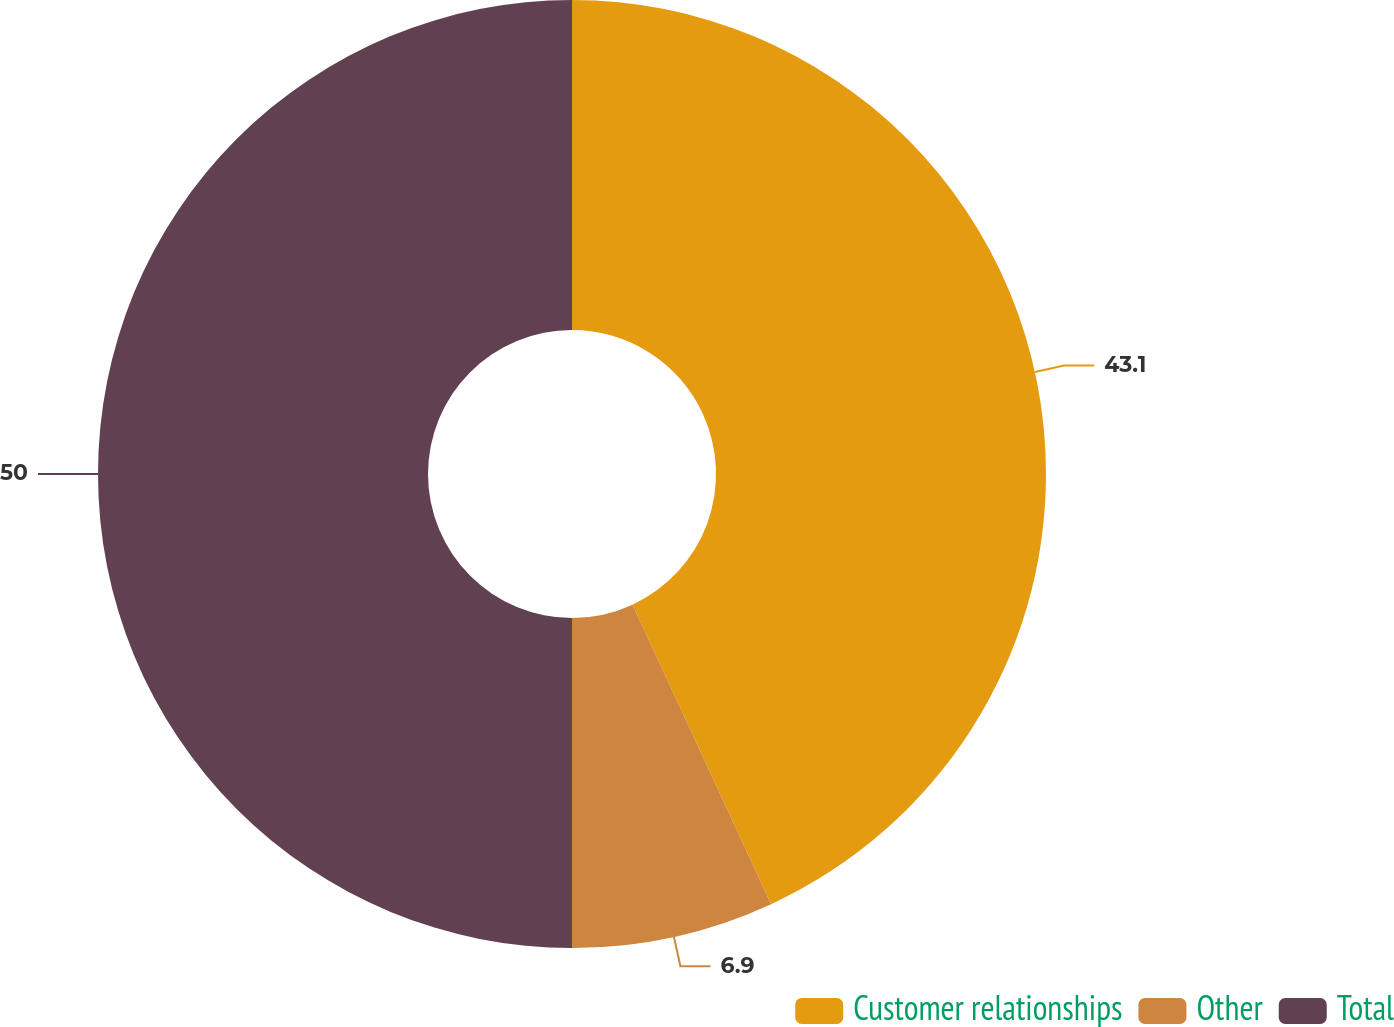Convert chart to OTSL. <chart><loc_0><loc_0><loc_500><loc_500><pie_chart><fcel>Customer relationships<fcel>Other<fcel>Total<nl><fcel>43.1%<fcel>6.9%<fcel>50.0%<nl></chart> 